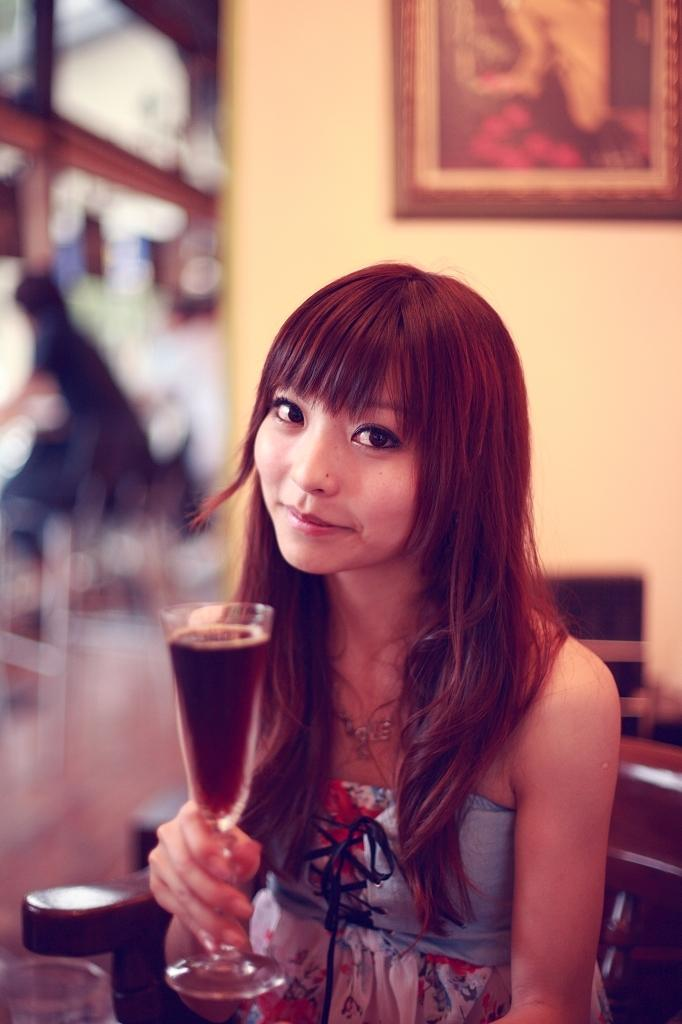Who is the main subject in the image? There is a girl in the image. What is the girl doing in the image? The girl is sitting. What is the girl holding in her hand? The girl is holding a glass in her hand. What is inside the glass? The glass contains a drink. What can be seen in the background of the image? There is a wall, a photo frame, and a chair in the background of the image. What is the value of the rail in the image? There is no rail present in the image. How does the steam affect the girl in the image? There is no steam present in the image. 